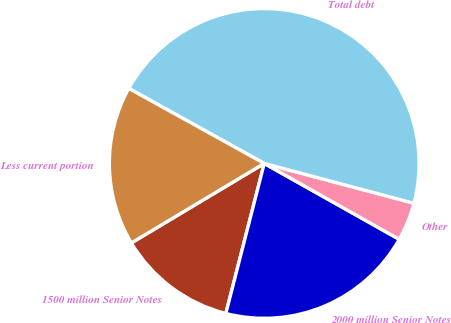Convert chart to OTSL. <chart><loc_0><loc_0><loc_500><loc_500><pie_chart><fcel>1500 million Senior Notes<fcel>2000 million Senior Notes<fcel>Other<fcel>Total debt<fcel>Less current portion<nl><fcel>12.43%<fcel>20.84%<fcel>4.01%<fcel>46.09%<fcel>16.63%<nl></chart> 